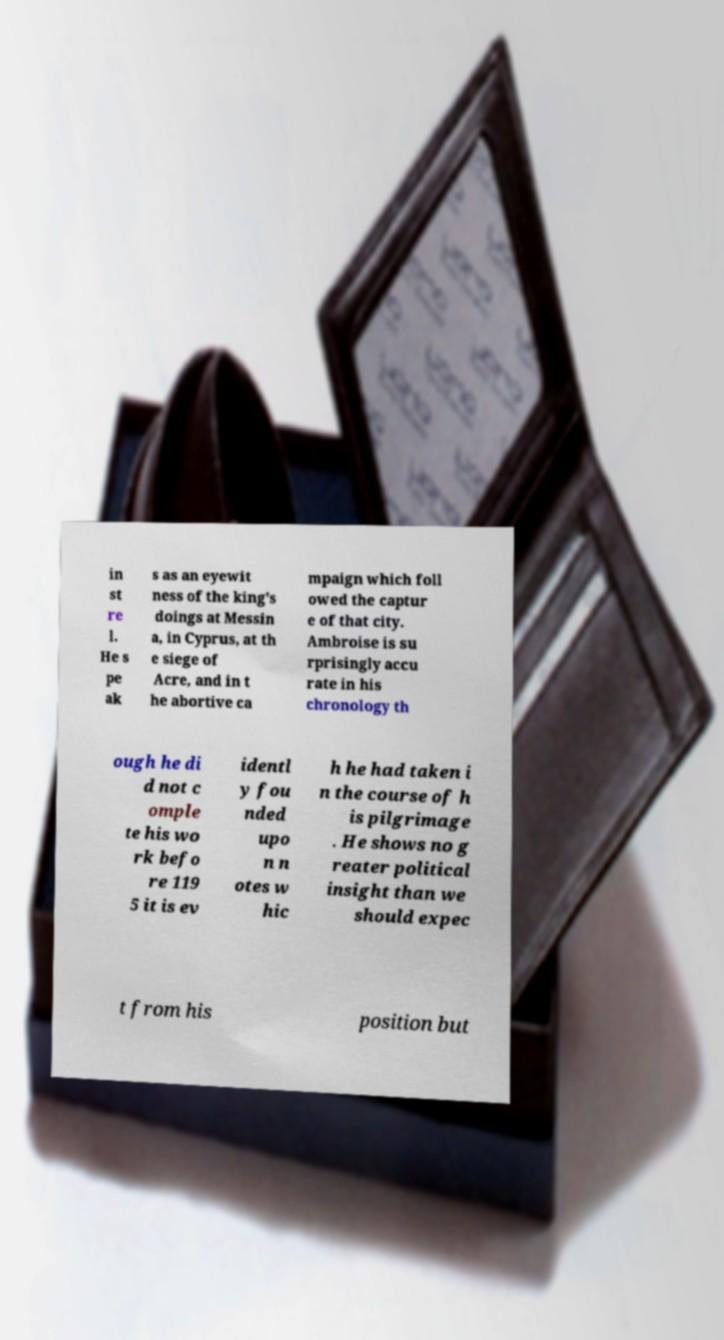There's text embedded in this image that I need extracted. Can you transcribe it verbatim? in st re l. He s pe ak s as an eyewit ness of the king's doings at Messin a, in Cyprus, at th e siege of Acre, and in t he abortive ca mpaign which foll owed the captur e of that city. Ambroise is su rprisingly accu rate in his chronology th ough he di d not c omple te his wo rk befo re 119 5 it is ev identl y fou nded upo n n otes w hic h he had taken i n the course of h is pilgrimage . He shows no g reater political insight than we should expec t from his position but 